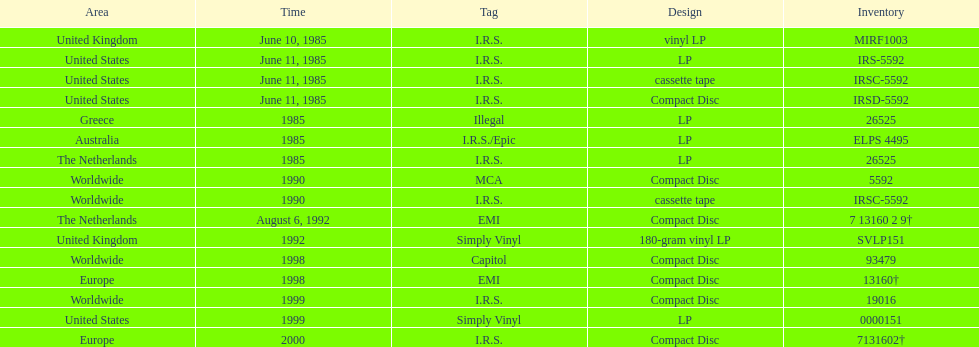Which is the unique region with vinyl lp format? United Kingdom. 